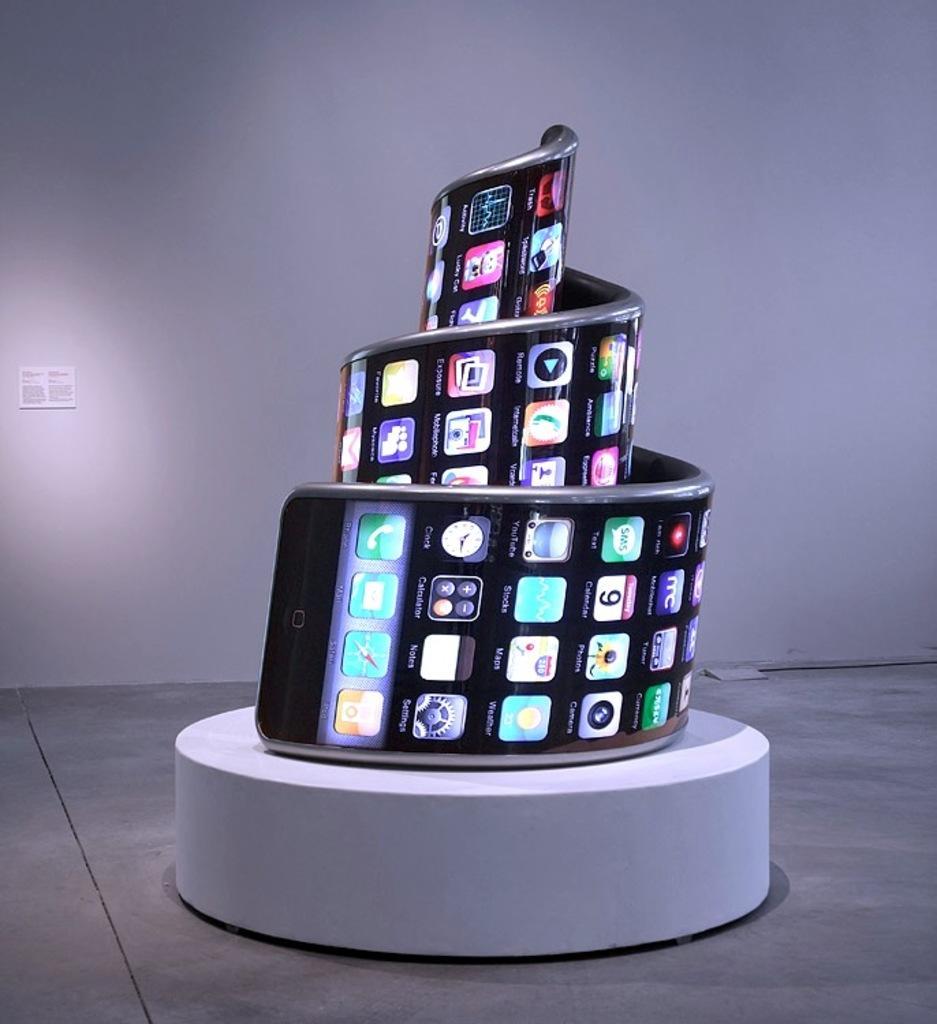Could you give a brief overview of what you see in this image? Here we can see a mobile is twisted into a spring like structure on a platform on the floor. In the background there is a small board on the wall. 